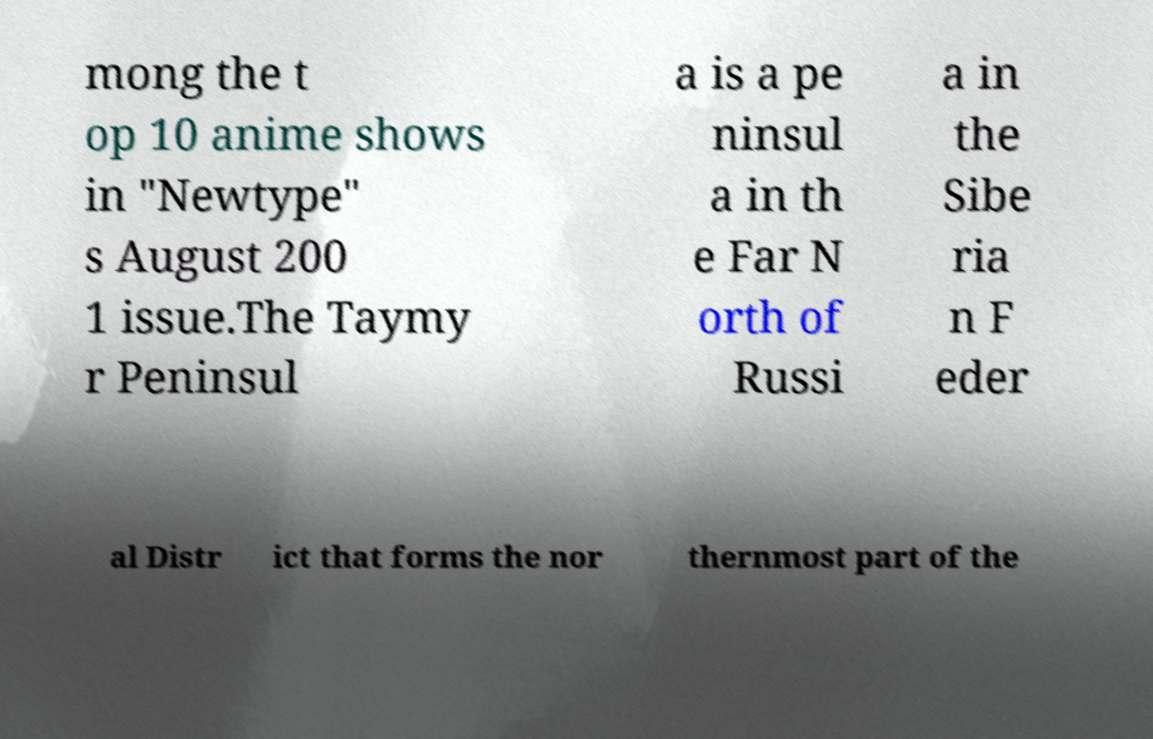Could you assist in decoding the text presented in this image and type it out clearly? mong the t op 10 anime shows in "Newtype" s August 200 1 issue.The Taymy r Peninsul a is a pe ninsul a in th e Far N orth of Russi a in the Sibe ria n F eder al Distr ict that forms the nor thernmost part of the 